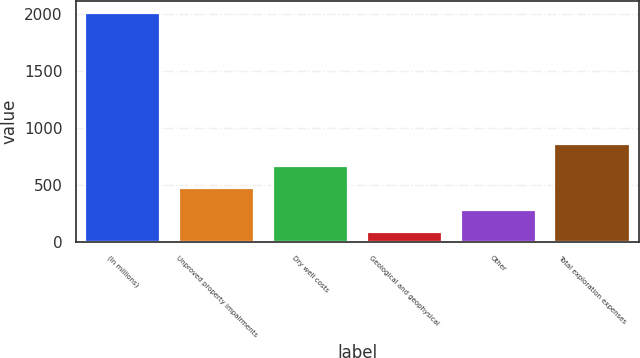Convert chart. <chart><loc_0><loc_0><loc_500><loc_500><bar_chart><fcel>(In millions)<fcel>Unproved property impairments<fcel>Dry well costs<fcel>Geological and geophysical<fcel>Other<fcel>Total exploration expenses<nl><fcel>2014<fcel>470.8<fcel>663.7<fcel>85<fcel>277.9<fcel>856.6<nl></chart> 